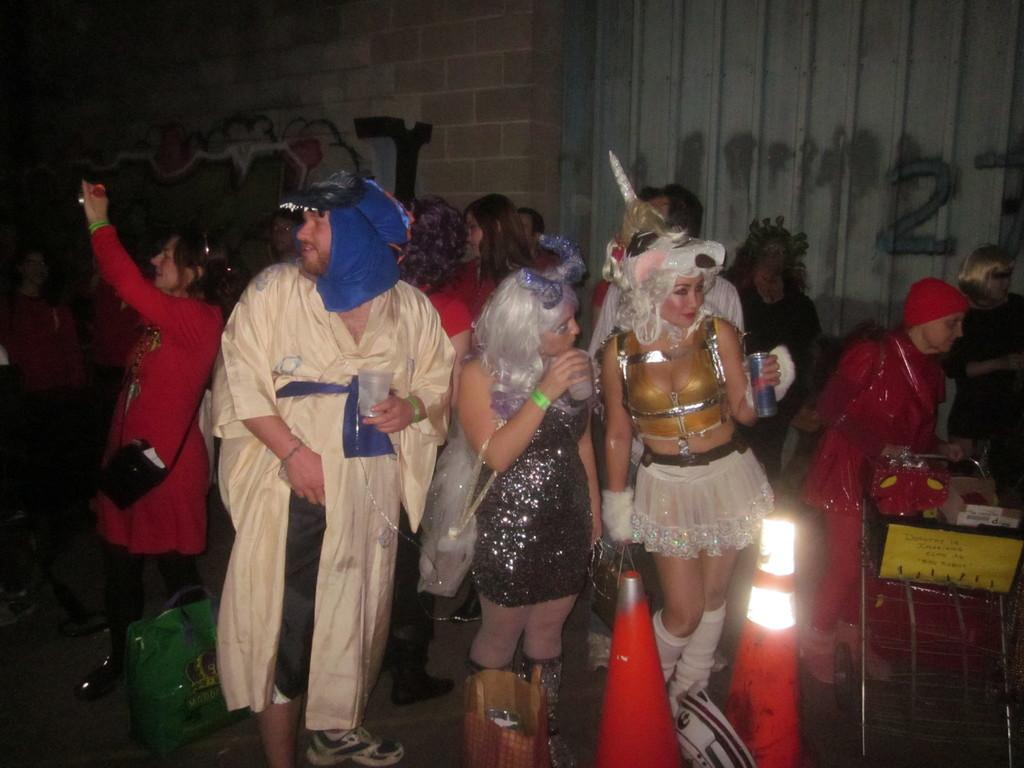How many people are in the image? There are many people in the image. What are the people in the image doing? The people are standing. What are the people wearing in the image? The people are wearing fancy costumes. Can you describe the woman on the left side of the image? The woman on the left side of the image is taking pictures. What type of whistle can be heard in the image? There is no whistle present in the image, and therefore no sound can be heard. Can you see a tub in the image? There is no tub present in the image. 